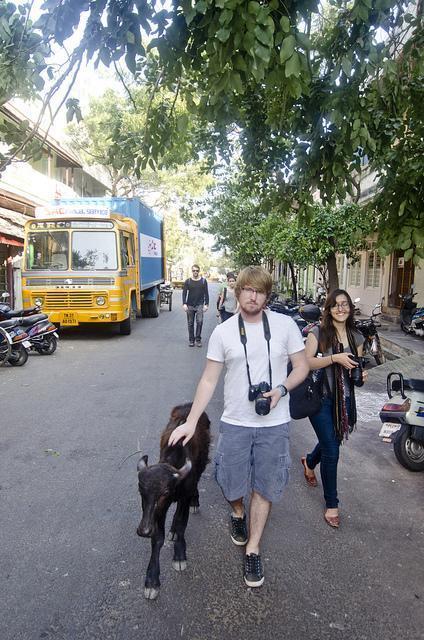How many people are there?
Give a very brief answer. 2. 